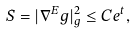Convert formula to latex. <formula><loc_0><loc_0><loc_500><loc_500>S = | \nabla ^ { E } g | ^ { 2 } _ { g } \leq C e ^ { t } ,</formula> 